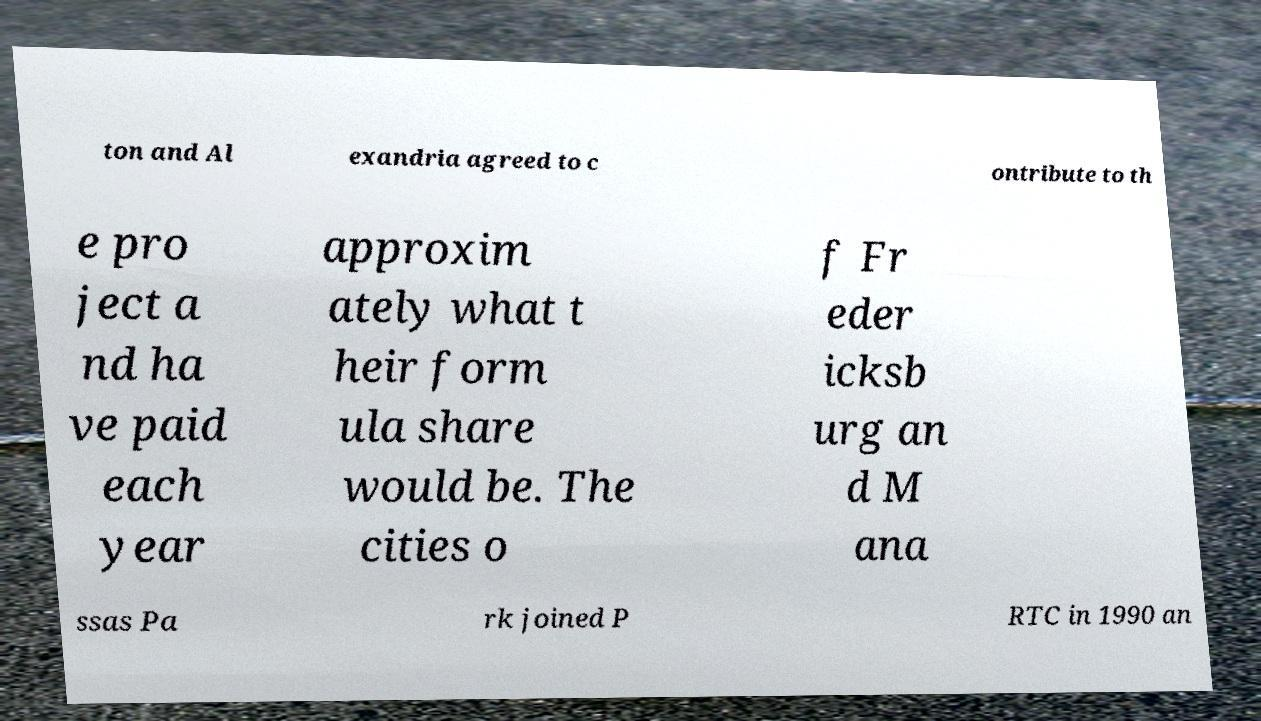Please identify and transcribe the text found in this image. ton and Al exandria agreed to c ontribute to th e pro ject a nd ha ve paid each year approxim ately what t heir form ula share would be. The cities o f Fr eder icksb urg an d M ana ssas Pa rk joined P RTC in 1990 an 